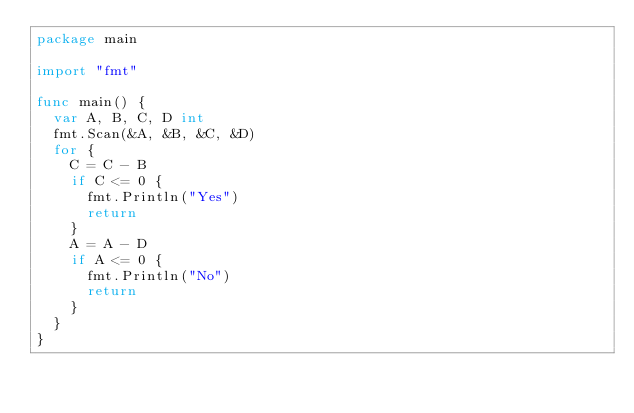<code> <loc_0><loc_0><loc_500><loc_500><_Go_>package main

import "fmt"

func main() {
	var A, B, C, D int
	fmt.Scan(&A, &B, &C, &D)
	for {
		C = C - B
		if C <= 0 {
			fmt.Println("Yes")
			return
		}
		A = A - D
		if A <= 0 {
			fmt.Println("No")
			return
		}
	}
}
</code> 